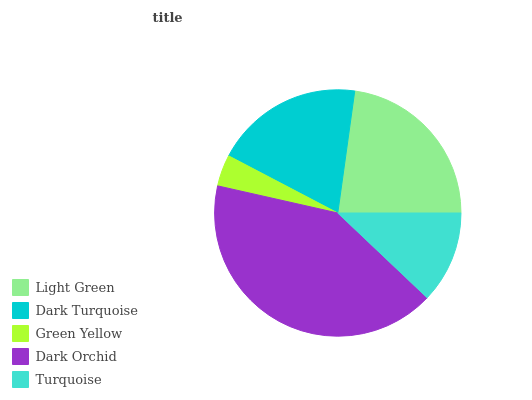Is Green Yellow the minimum?
Answer yes or no. Yes. Is Dark Orchid the maximum?
Answer yes or no. Yes. Is Dark Turquoise the minimum?
Answer yes or no. No. Is Dark Turquoise the maximum?
Answer yes or no. No. Is Light Green greater than Dark Turquoise?
Answer yes or no. Yes. Is Dark Turquoise less than Light Green?
Answer yes or no. Yes. Is Dark Turquoise greater than Light Green?
Answer yes or no. No. Is Light Green less than Dark Turquoise?
Answer yes or no. No. Is Dark Turquoise the high median?
Answer yes or no. Yes. Is Dark Turquoise the low median?
Answer yes or no. Yes. Is Light Green the high median?
Answer yes or no. No. Is Dark Orchid the low median?
Answer yes or no. No. 